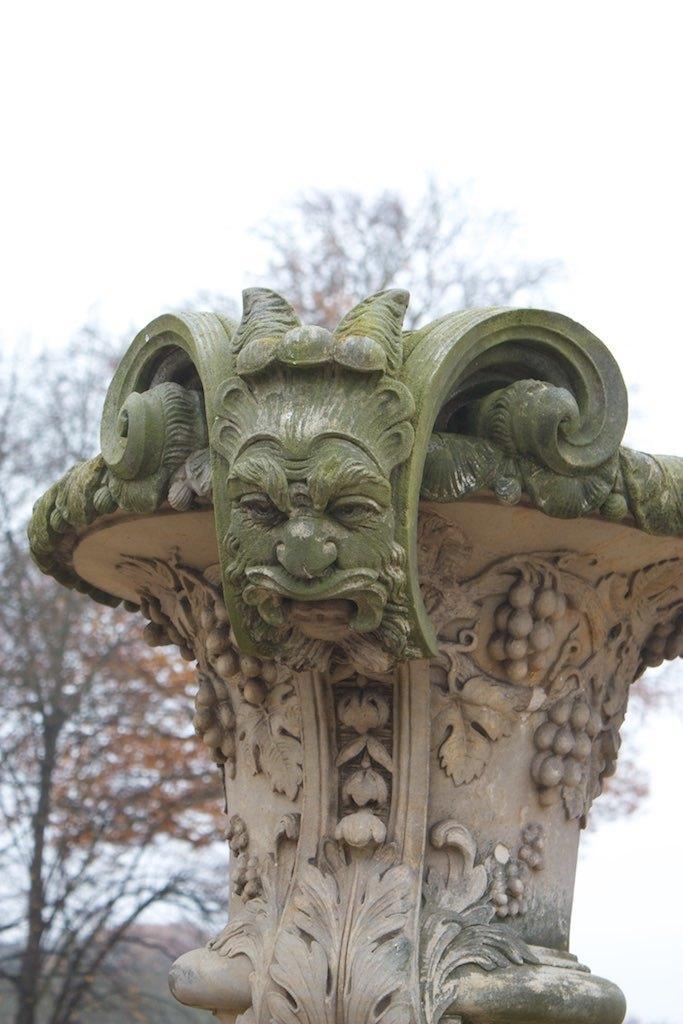How would you summarize this image in a sentence or two? This is the picture of carved stone. In the background, there are trees. At the top of the picture, we see the sky. 